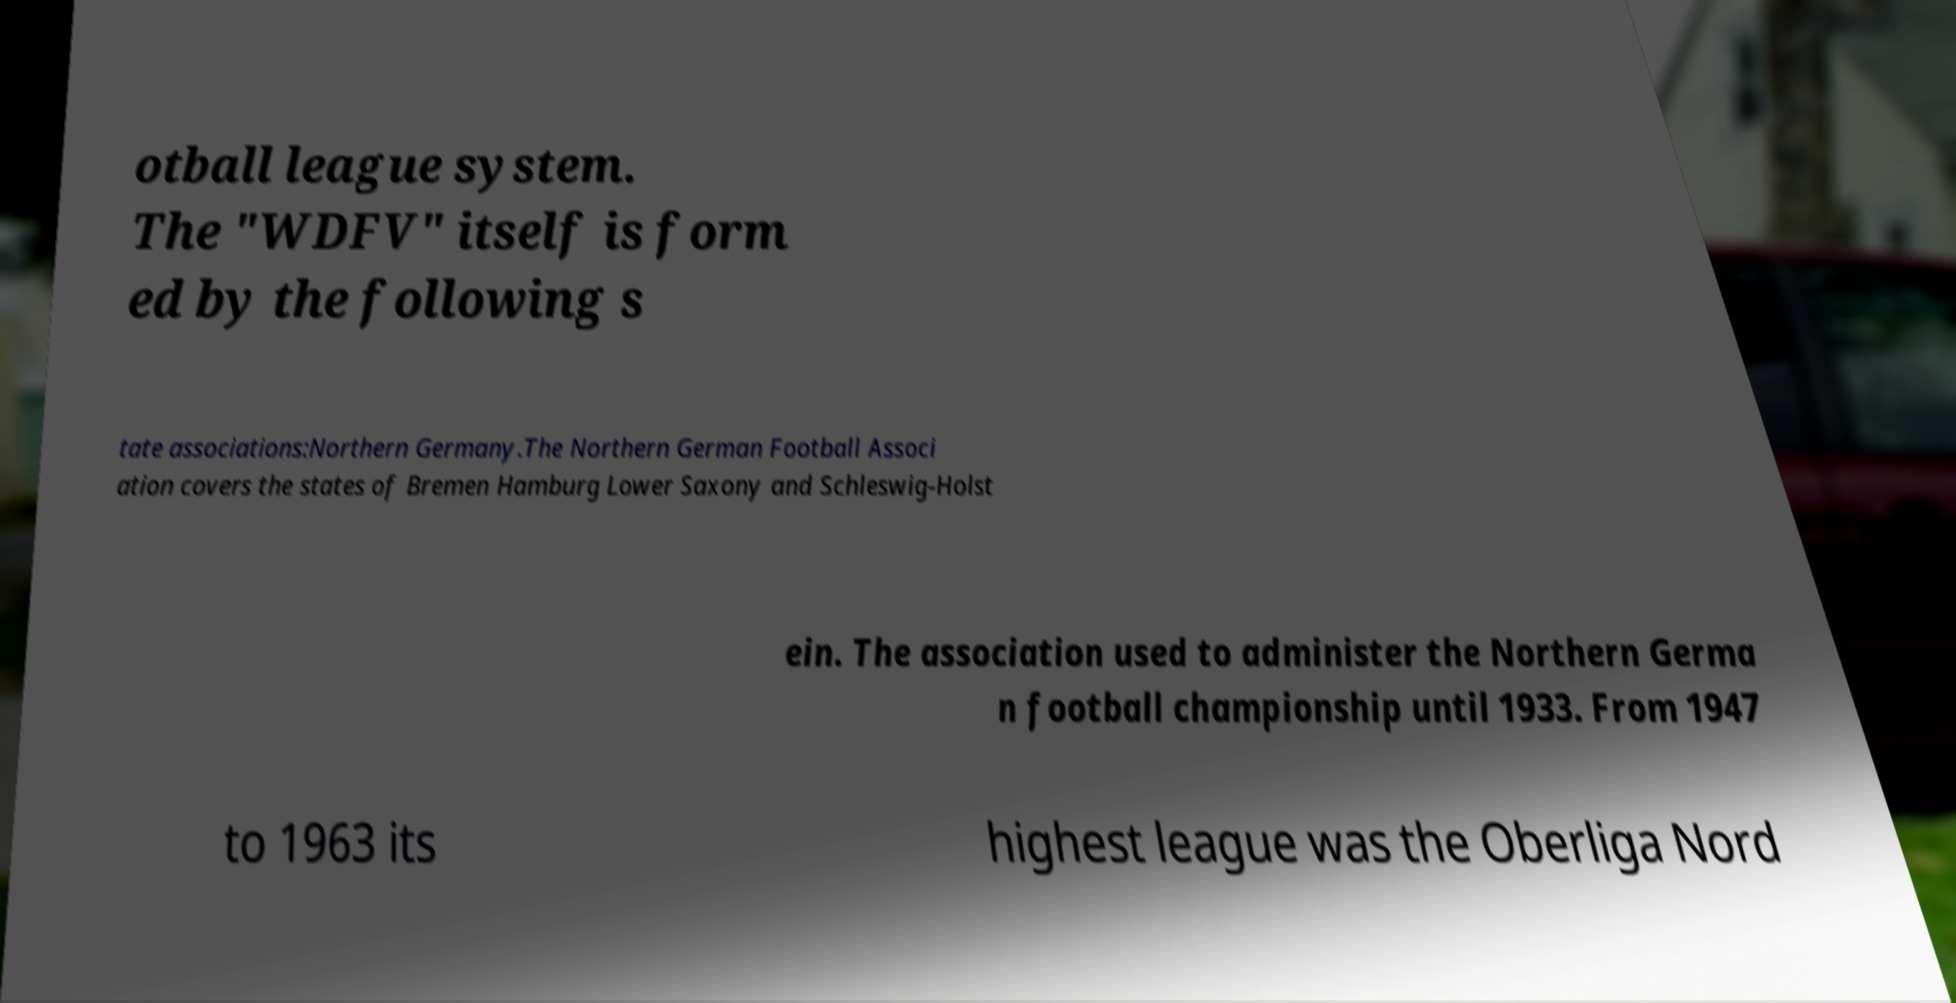Can you read and provide the text displayed in the image?This photo seems to have some interesting text. Can you extract and type it out for me? otball league system. The "WDFV" itself is form ed by the following s tate associations:Northern Germany.The Northern German Football Associ ation covers the states of Bremen Hamburg Lower Saxony and Schleswig-Holst ein. The association used to administer the Northern Germa n football championship until 1933. From 1947 to 1963 its highest league was the Oberliga Nord 